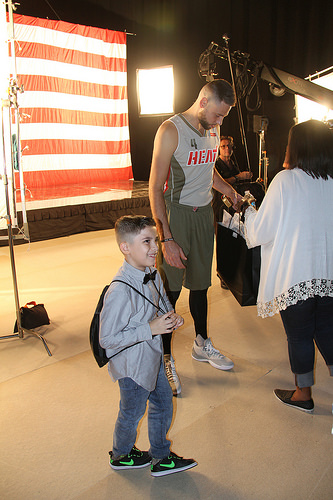<image>
Can you confirm if the kid is in front of the man? Yes. The kid is positioned in front of the man, appearing closer to the camera viewpoint. Is there a boy in front of the man? Yes. The boy is positioned in front of the man, appearing closer to the camera viewpoint. 